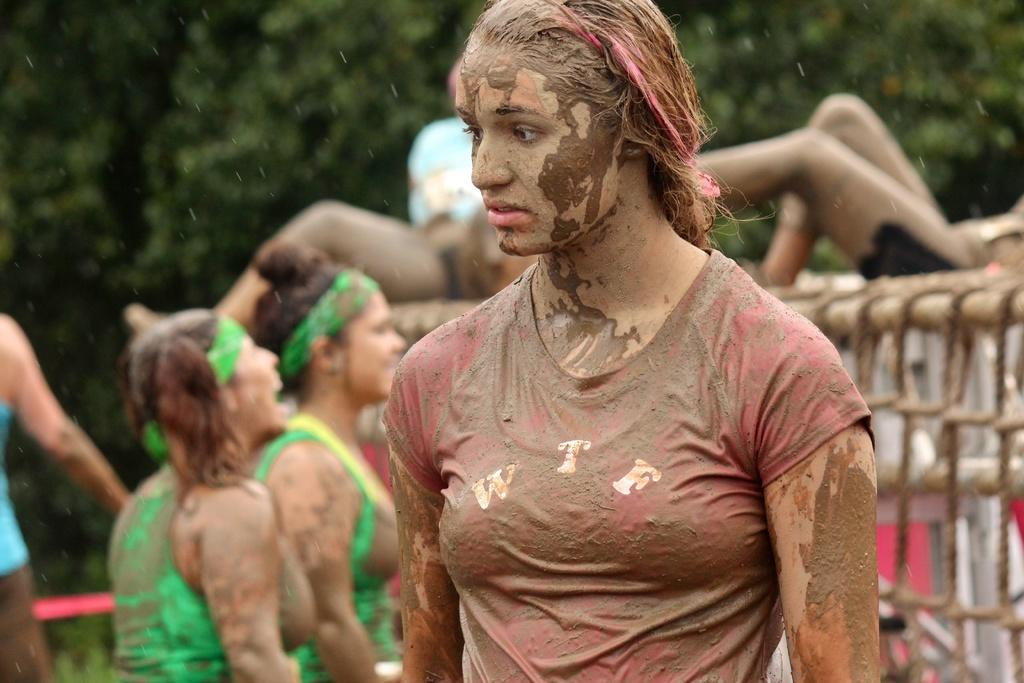What is the main subject of the image? A woman is standing in the image. What is the condition of the woman in the image? The woman is covered with mud. Can you describe the background of the image? There are other people and trees in the background of the image. What type of lock can be seen on the fowl in the image? There is no fowl or lock present in the image. What color are the woman's eyes in the image? The provided facts do not mention the color of the woman's eyes, so we cannot determine that information from the image. 